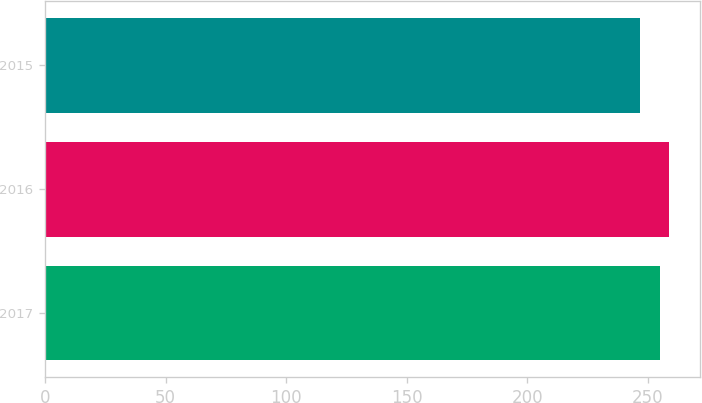<chart> <loc_0><loc_0><loc_500><loc_500><bar_chart><fcel>2017<fcel>2016<fcel>2015<nl><fcel>255<fcel>259<fcel>247<nl></chart> 